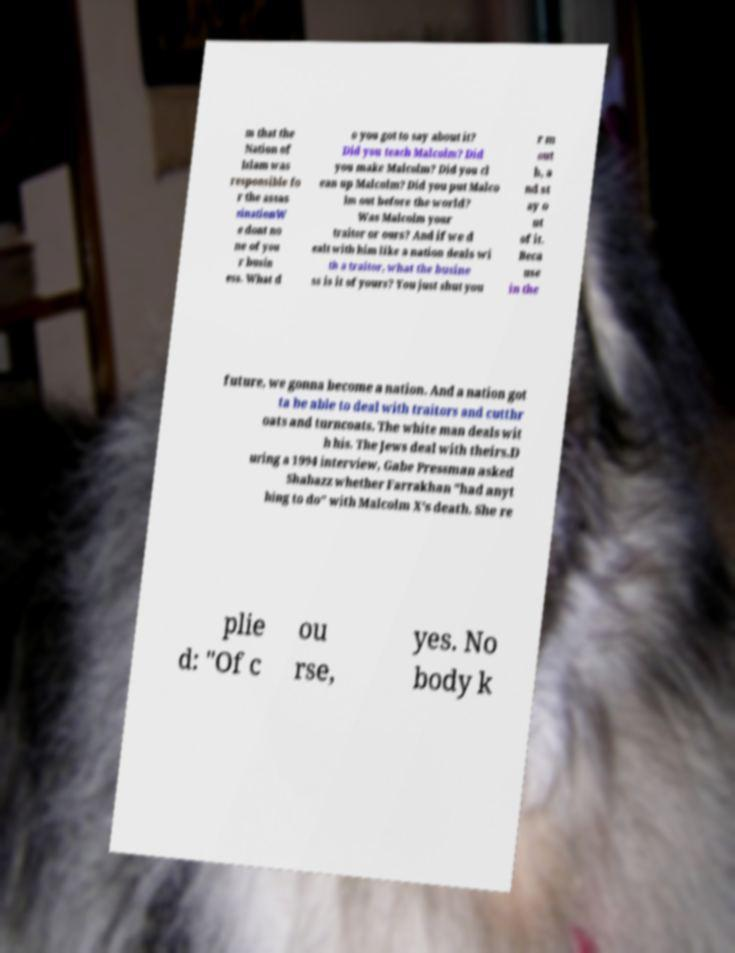Please read and relay the text visible in this image. What does it say? m that the Nation of Islam was responsible fo r the assas sinationW e dont no ne of you r busin ess. What d o you got to say about it? Did you teach Malcolm? Did you make Malcolm? Did you cl ean up Malcolm? Did you put Malco lm out before the world? Was Malcolm your traitor or ours? And if we d ealt with him like a nation deals wi th a traitor, what the busine ss is it of yours? You just shut you r m out h, a nd st ay o ut of it. Beca use in the future, we gonna become a nation. And a nation got ta be able to deal with traitors and cutthr oats and turncoats. The white man deals wit h his. The Jews deal with theirs.D uring a 1994 interview, Gabe Pressman asked Shabazz whether Farrakhan "had anyt hing to do" with Malcolm X's death. She re plie d: "Of c ou rse, yes. No body k 